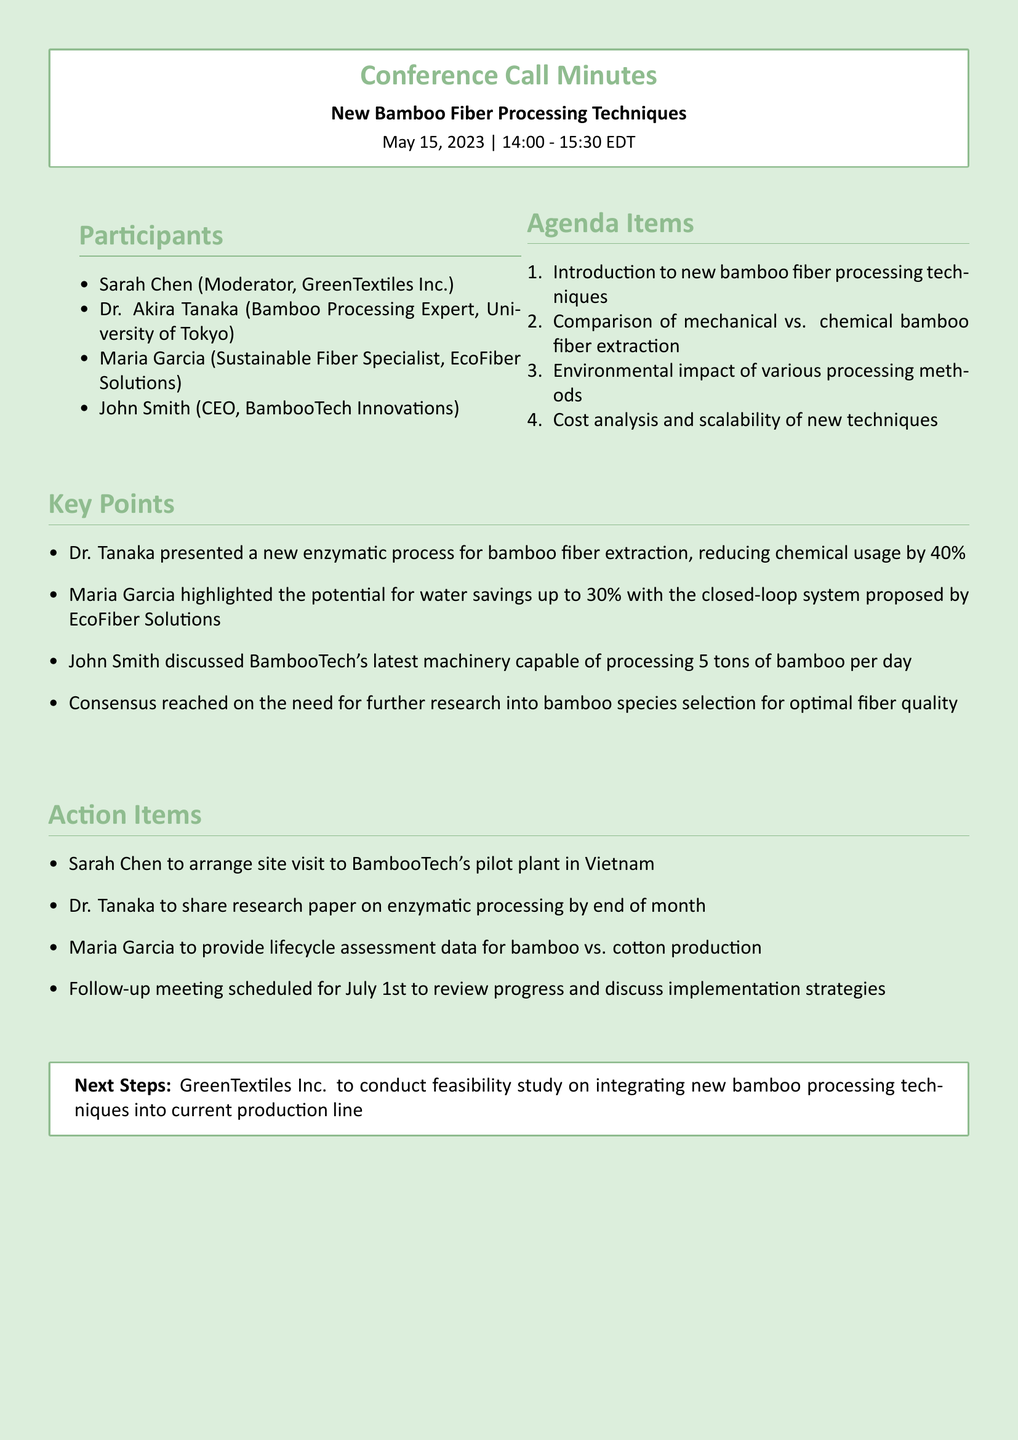What is the date of the conference call? The conference call is dated May 15, 2023.
Answer: May 15, 2023 Who is the CEO of BambooTech Innovations? John Smith is listed as the CEO of BambooTech Innovations.
Answer: John Smith What is the maximum daily processing capacity of BambooTech's machinery? John Smith discussed a machinery capable of processing 5 tons of bamboo per day.
Answer: 5 tons What percentage reduction in chemical usage was presented by Dr. Tanaka? Dr. Tanaka presented a reduction of 40% in chemical usage through a new process.
Answer: 40% What item is Sarah Chen responsible for after the call? Sarah Chen is to arrange a site visit to BambooTech's pilot plant in Vietnam.
Answer: Site visit to BambooTech's pilot plant What is the follow-up meeting date scheduled for? The follow-up meeting is scheduled for July 1st.
Answer: July 1st What type of processing method showed potential water savings of 30%? Maria Garcia highlighted a closed-loop system proposed by EcoFiber Solutions.
Answer: Closed-loop system What was the consensus reached among the participants? There was a consensus on the need for further research into bamboo species selection for optimal fiber quality.
Answer: Further research on bamboo species selection 